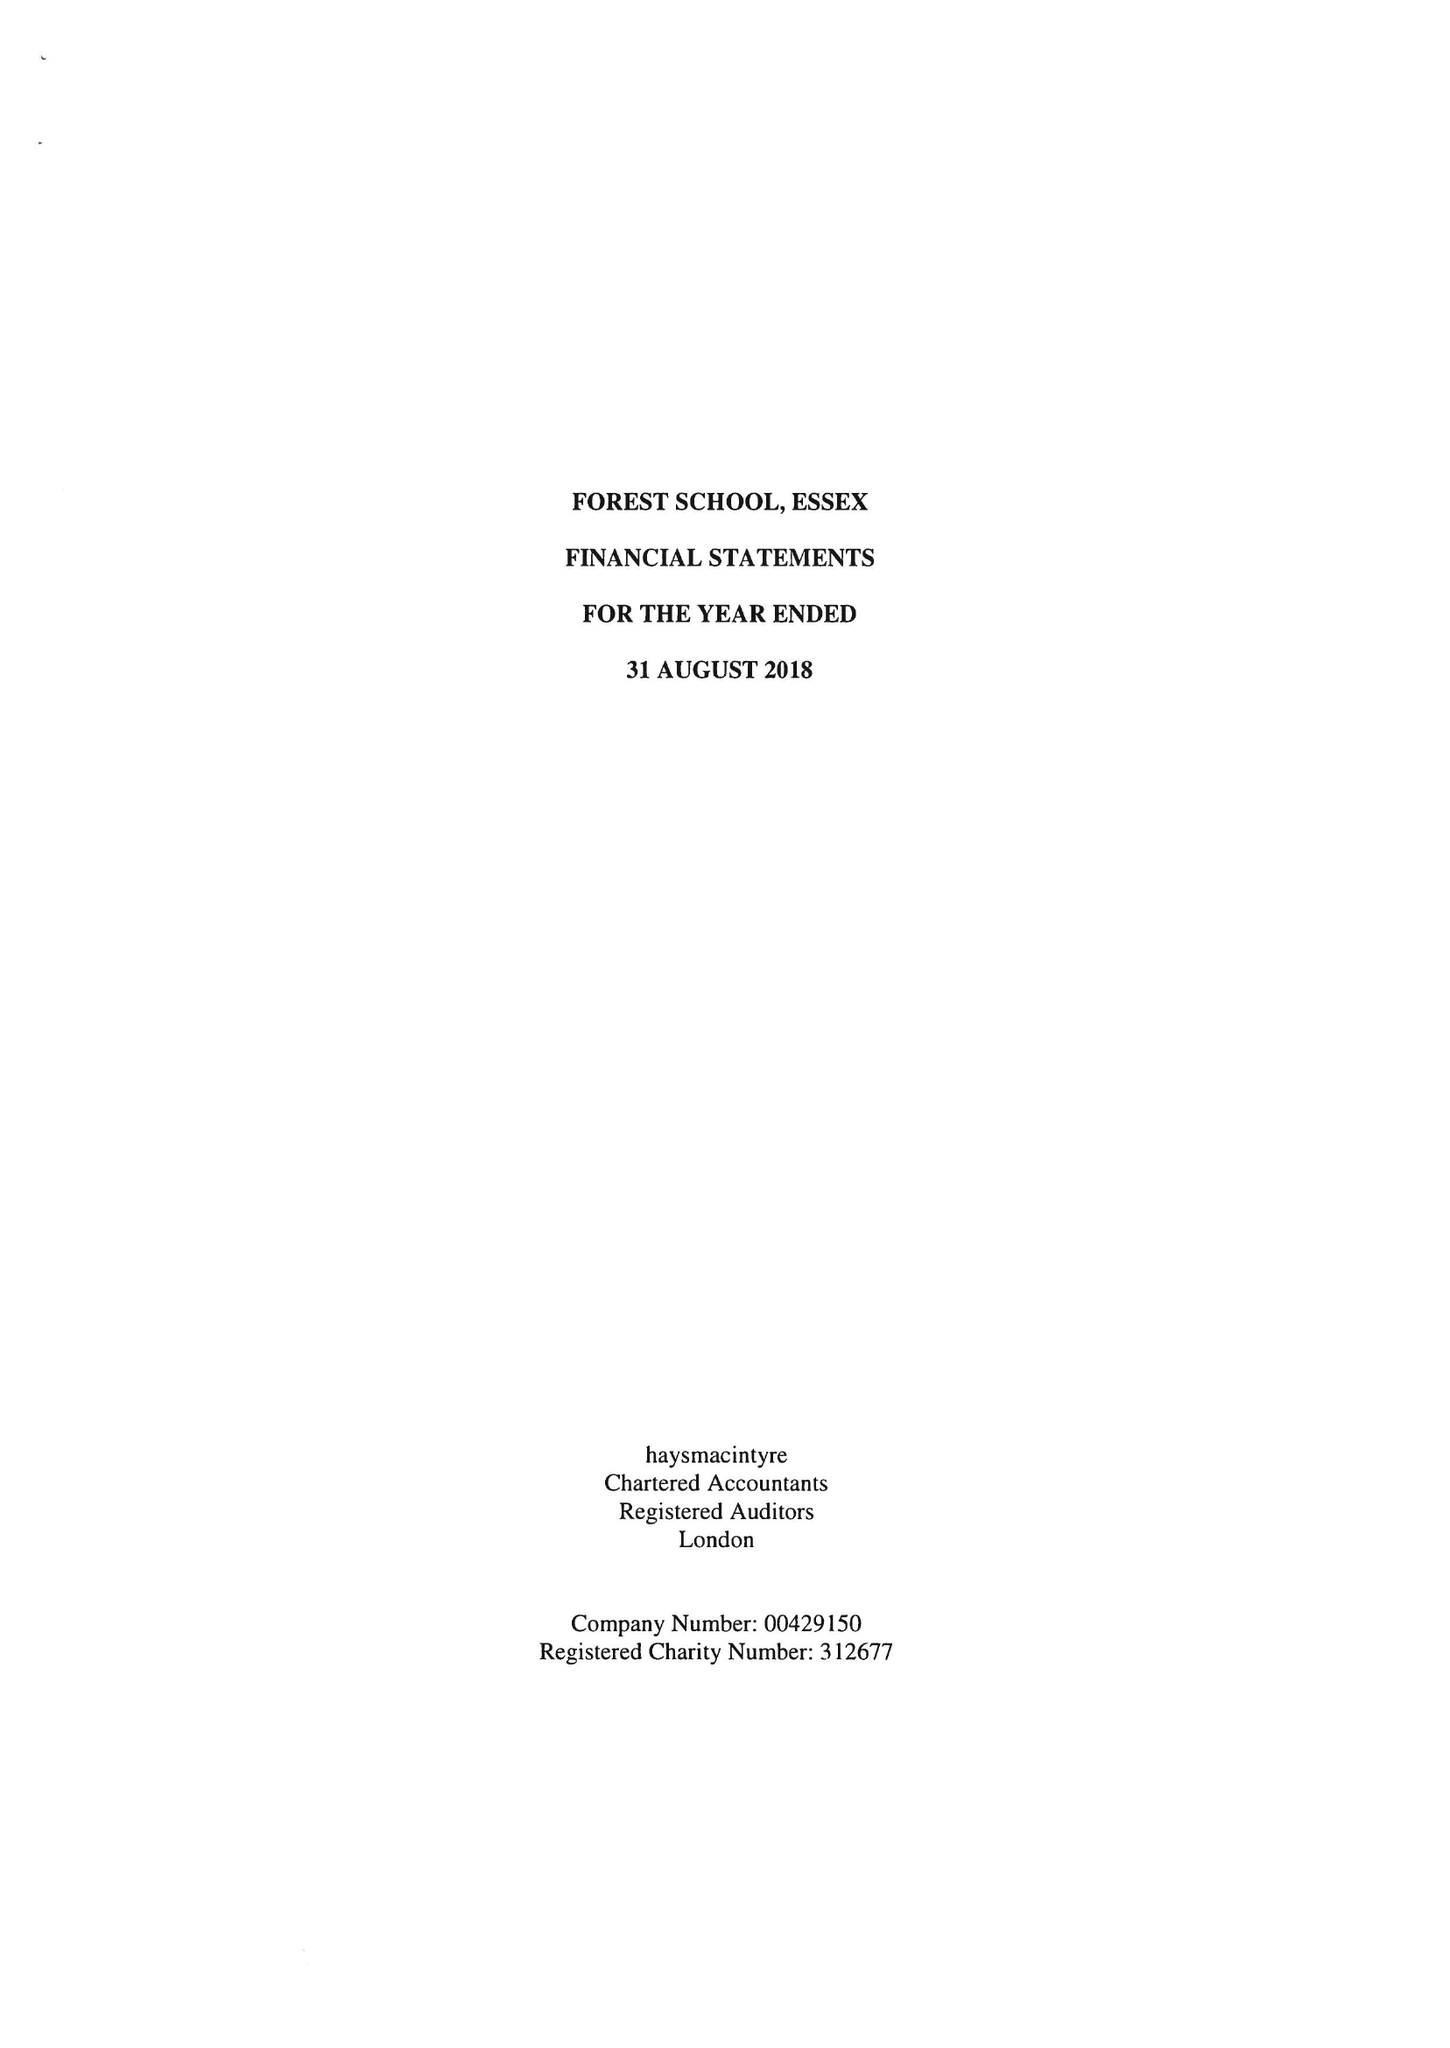What is the value for the address__postcode?
Answer the question using a single word or phrase. E17 3PY 